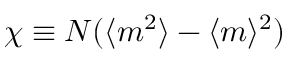Convert formula to latex. <formula><loc_0><loc_0><loc_500><loc_500>\chi \equiv N ( \langle m ^ { 2 } \rangle - \langle m \rangle ^ { 2 } )</formula> 